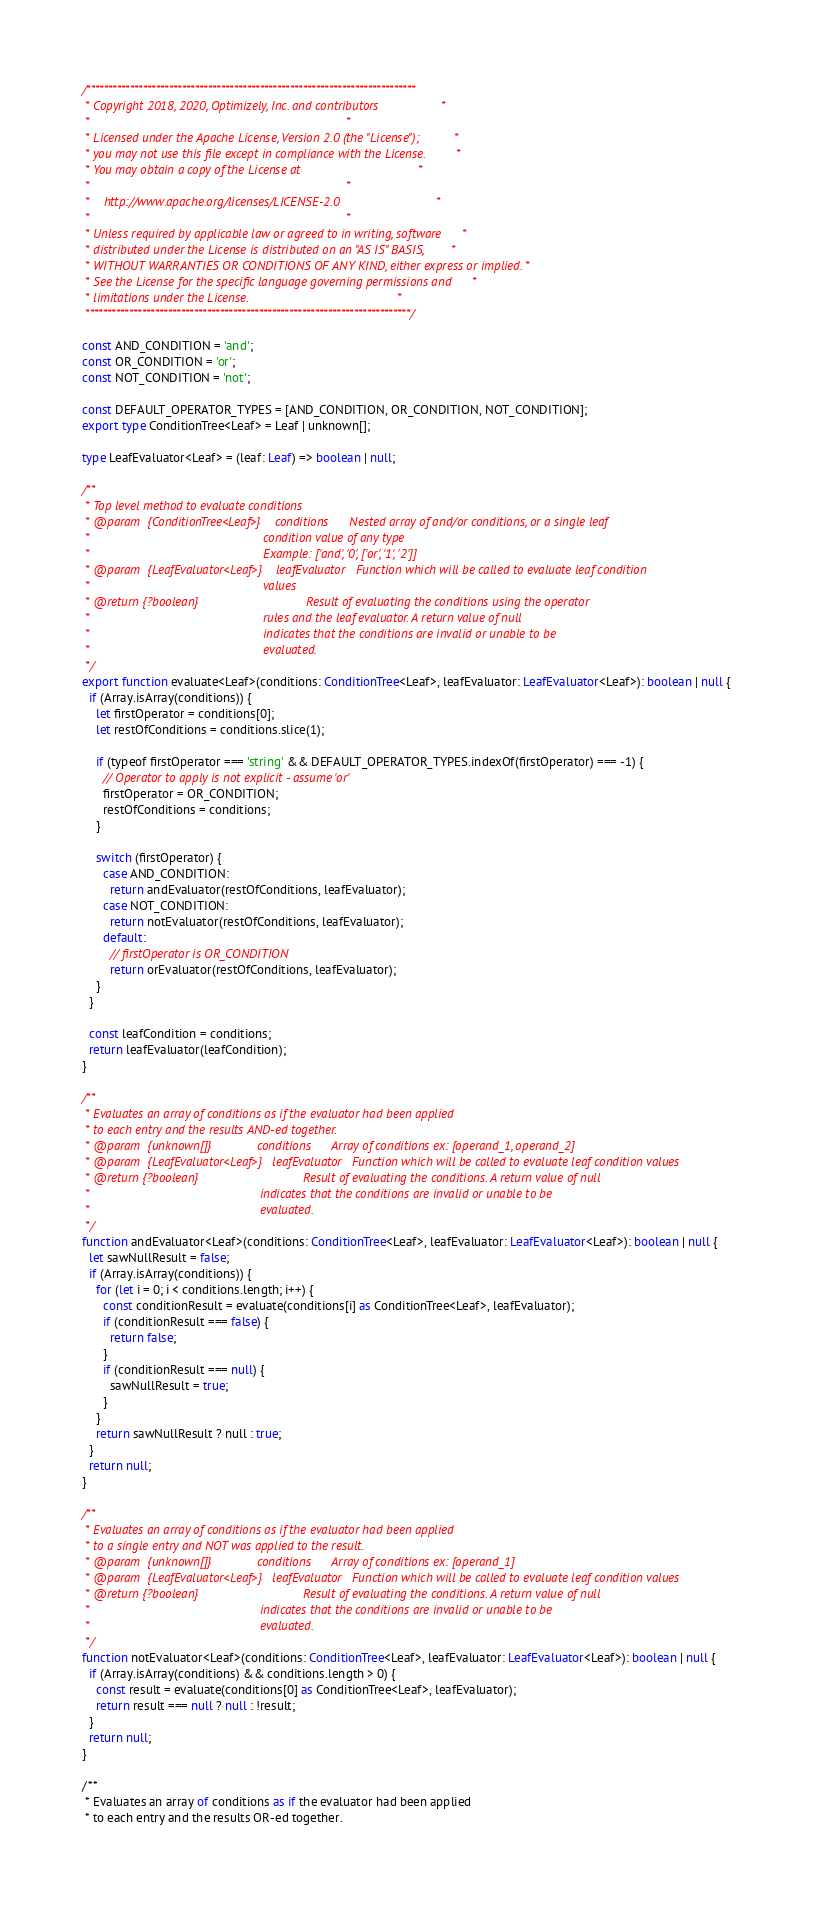Convert code to text. <code><loc_0><loc_0><loc_500><loc_500><_TypeScript_>/****************************************************************************
 * Copyright 2018, 2020, Optimizely, Inc. and contributors                  *
 *                                                                          *
 * Licensed under the Apache License, Version 2.0 (the "License");          *
 * you may not use this file except in compliance with the License.         *
 * You may obtain a copy of the License at                                  *
 *                                                                          *
 *    http://www.apache.org/licenses/LICENSE-2.0                            *
 *                                                                          *
 * Unless required by applicable law or agreed to in writing, software      *
 * distributed under the License is distributed on an "AS IS" BASIS,        *
 * WITHOUT WARRANTIES OR CONDITIONS OF ANY KIND, either express or implied. *
 * See the License for the specific language governing permissions and      *
 * limitations under the License.                                           *
 ***************************************************************************/

const AND_CONDITION = 'and';
const OR_CONDITION = 'or';
const NOT_CONDITION = 'not';

const DEFAULT_OPERATOR_TYPES = [AND_CONDITION, OR_CONDITION, NOT_CONDITION];
export type ConditionTree<Leaf> = Leaf | unknown[];

type LeafEvaluator<Leaf> = (leaf: Leaf) => boolean | null;

/**
 * Top level method to evaluate conditions
 * @param  {ConditionTree<Leaf>}    conditions      Nested array of and/or conditions, or a single leaf
 *                                                  condition value of any type
 *                                                  Example: ['and', '0', ['or', '1', '2']]
 * @param  {LeafEvaluator<Leaf>}    leafEvaluator   Function which will be called to evaluate leaf condition
 *                                                  values
 * @return {?boolean}                               Result of evaluating the conditions using the operator
 *                                                  rules and the leaf evaluator. A return value of null
 *                                                  indicates that the conditions are invalid or unable to be
 *                                                  evaluated.
 */
export function evaluate<Leaf>(conditions: ConditionTree<Leaf>, leafEvaluator: LeafEvaluator<Leaf>): boolean | null {
  if (Array.isArray(conditions)) {
    let firstOperator = conditions[0];
    let restOfConditions = conditions.slice(1);

    if (typeof firstOperator === 'string' && DEFAULT_OPERATOR_TYPES.indexOf(firstOperator) === -1) {
      // Operator to apply is not explicit - assume 'or'
      firstOperator = OR_CONDITION;
      restOfConditions = conditions;
    }

    switch (firstOperator) {
      case AND_CONDITION:
        return andEvaluator(restOfConditions, leafEvaluator);
      case NOT_CONDITION:
        return notEvaluator(restOfConditions, leafEvaluator);
      default:
        // firstOperator is OR_CONDITION
        return orEvaluator(restOfConditions, leafEvaluator);
    }
  }

  const leafCondition = conditions;
  return leafEvaluator(leafCondition);
}

/**
 * Evaluates an array of conditions as if the evaluator had been applied
 * to each entry and the results AND-ed together.
 * @param  {unknown[]}             conditions      Array of conditions ex: [operand_1, operand_2]
 * @param  {LeafEvaluator<Leaf>}   leafEvaluator   Function which will be called to evaluate leaf condition values
 * @return {?boolean}                              Result of evaluating the conditions. A return value of null
 *                                                 indicates that the conditions are invalid or unable to be
 *                                                 evaluated.
 */
function andEvaluator<Leaf>(conditions: ConditionTree<Leaf>, leafEvaluator: LeafEvaluator<Leaf>): boolean | null {
  let sawNullResult = false;
  if (Array.isArray(conditions)) {
    for (let i = 0; i < conditions.length; i++) {
      const conditionResult = evaluate(conditions[i] as ConditionTree<Leaf>, leafEvaluator);
      if (conditionResult === false) {
        return false;
      }
      if (conditionResult === null) {
        sawNullResult = true;
      }
    }
    return sawNullResult ? null : true;
  }
  return null;
}

/**
 * Evaluates an array of conditions as if the evaluator had been applied
 * to a single entry and NOT was applied to the result.
 * @param  {unknown[]}             conditions      Array of conditions ex: [operand_1]
 * @param  {LeafEvaluator<Leaf>}   leafEvaluator   Function which will be called to evaluate leaf condition values
 * @return {?boolean}                              Result of evaluating the conditions. A return value of null
 *                                                 indicates that the conditions are invalid or unable to be
 *                                                 evaluated.
 */
function notEvaluator<Leaf>(conditions: ConditionTree<Leaf>, leafEvaluator: LeafEvaluator<Leaf>): boolean | null {
  if (Array.isArray(conditions) && conditions.length > 0) {
    const result = evaluate(conditions[0] as ConditionTree<Leaf>, leafEvaluator);
    return result === null ? null : !result;
  }
  return null;
}

/**
 * Evaluates an array of conditions as if the evaluator had been applied
 * to each entry and the results OR-ed together.</code> 